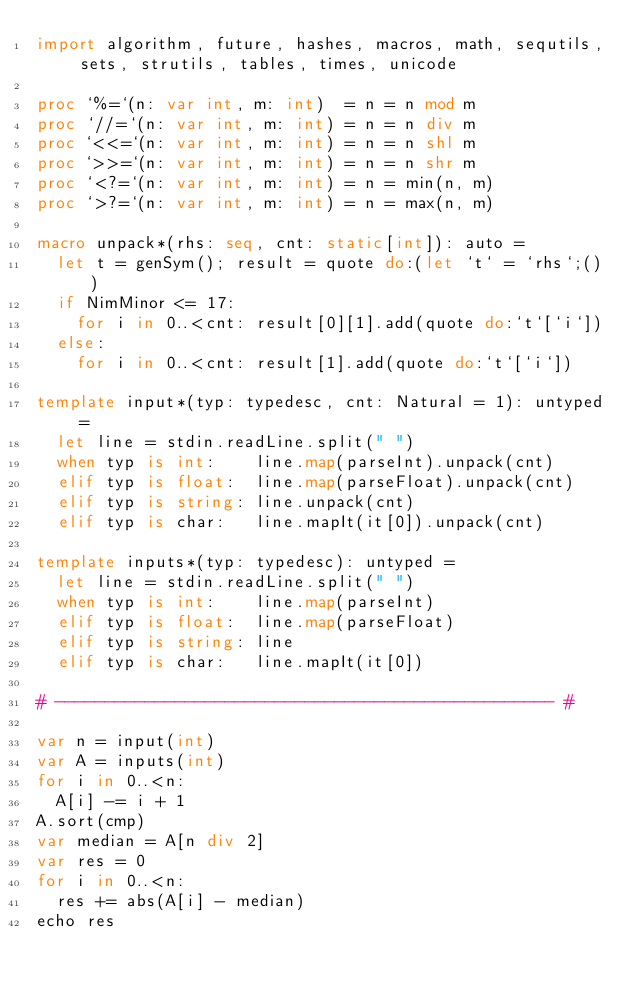<code> <loc_0><loc_0><loc_500><loc_500><_Nim_>import algorithm, future, hashes, macros, math, sequtils, sets, strutils, tables, times, unicode

proc `%=`(n: var int, m: int)  = n = n mod m
proc `//=`(n: var int, m: int) = n = n div m
proc `<<=`(n: var int, m: int) = n = n shl m
proc `>>=`(n: var int, m: int) = n = n shr m
proc `<?=`(n: var int, m: int) = n = min(n, m)
proc `>?=`(n: var int, m: int) = n = max(n, m)

macro unpack*(rhs: seq, cnt: static[int]): auto =
  let t = genSym(); result = quote do:(let `t` = `rhs`;())
  if NimMinor <= 17:
    for i in 0..<cnt: result[0][1].add(quote do:`t`[`i`])
  else:
    for i in 0..<cnt: result[1].add(quote do:`t`[`i`])

template input*(typ: typedesc, cnt: Natural = 1): untyped =
  let line = stdin.readLine.split(" ")
  when typ is int:    line.map(parseInt).unpack(cnt)
  elif typ is float:  line.map(parseFloat).unpack(cnt)
  elif typ is string: line.unpack(cnt)
  elif typ is char:   line.mapIt(it[0]).unpack(cnt)

template inputs*(typ: typedesc): untyped =
  let line = stdin.readLine.split(" ")
  when typ is int:    line.map(parseInt)
  elif typ is float:  line.map(parseFloat)
  elif typ is string: line
  elif typ is char:   line.mapIt(it[0])

# -------------------------------------------------- #

var n = input(int)
var A = inputs(int)
for i in 0..<n:
  A[i] -= i + 1
A.sort(cmp)
var median = A[n div 2]
var res = 0
for i in 0..<n:
  res += abs(A[i] - median)
echo res</code> 